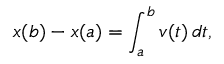<formula> <loc_0><loc_0><loc_500><loc_500>x ( b ) - x ( a ) = \int _ { a } ^ { b } v ( t ) \, d t ,</formula> 